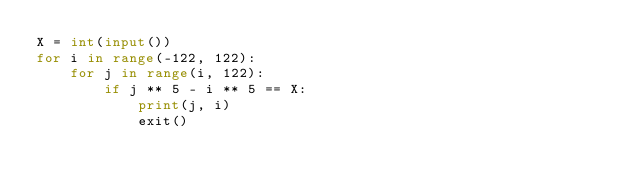Convert code to text. <code><loc_0><loc_0><loc_500><loc_500><_Python_>X = int(input())
for i in range(-122, 122):
    for j in range(i, 122):
        if j ** 5 - i ** 5 == X:
            print(j, i)
            exit()
</code> 